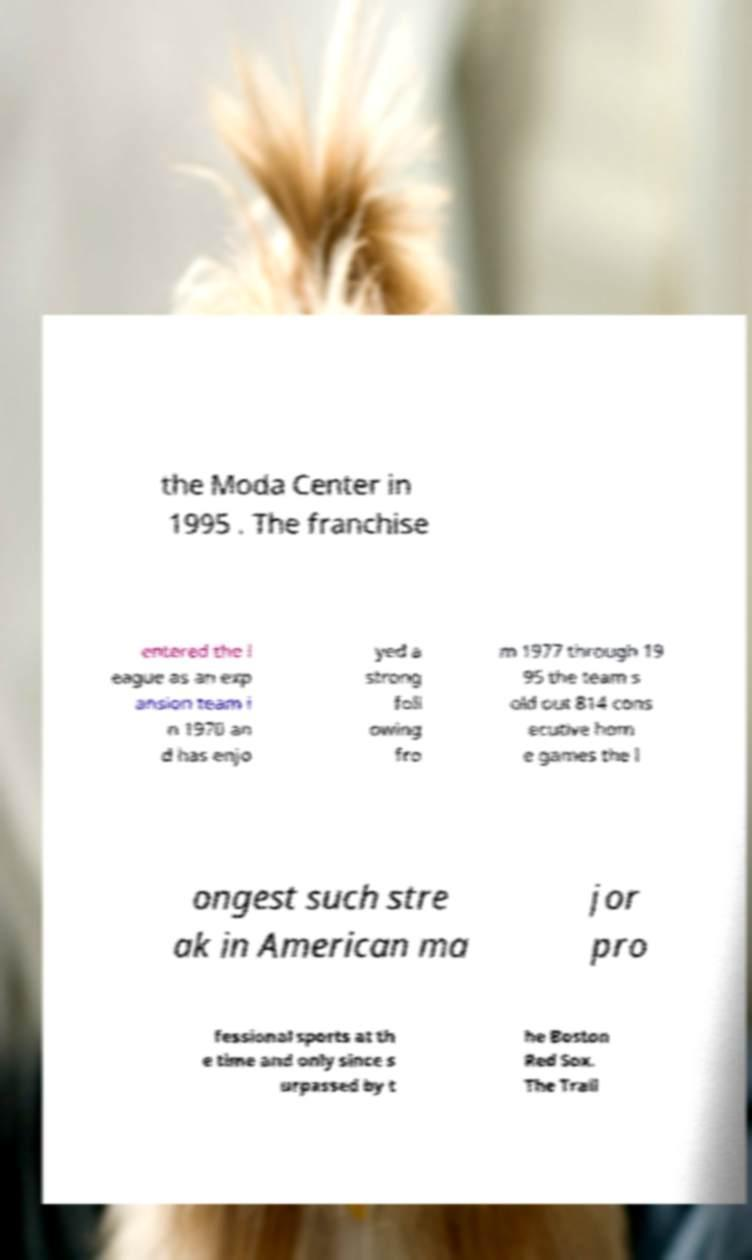There's text embedded in this image that I need extracted. Can you transcribe it verbatim? the Moda Center in 1995 . The franchise entered the l eague as an exp ansion team i n 1970 an d has enjo yed a strong foll owing fro m 1977 through 19 95 the team s old out 814 cons ecutive hom e games the l ongest such stre ak in American ma jor pro fessional sports at th e time and only since s urpassed by t he Boston Red Sox. The Trail 